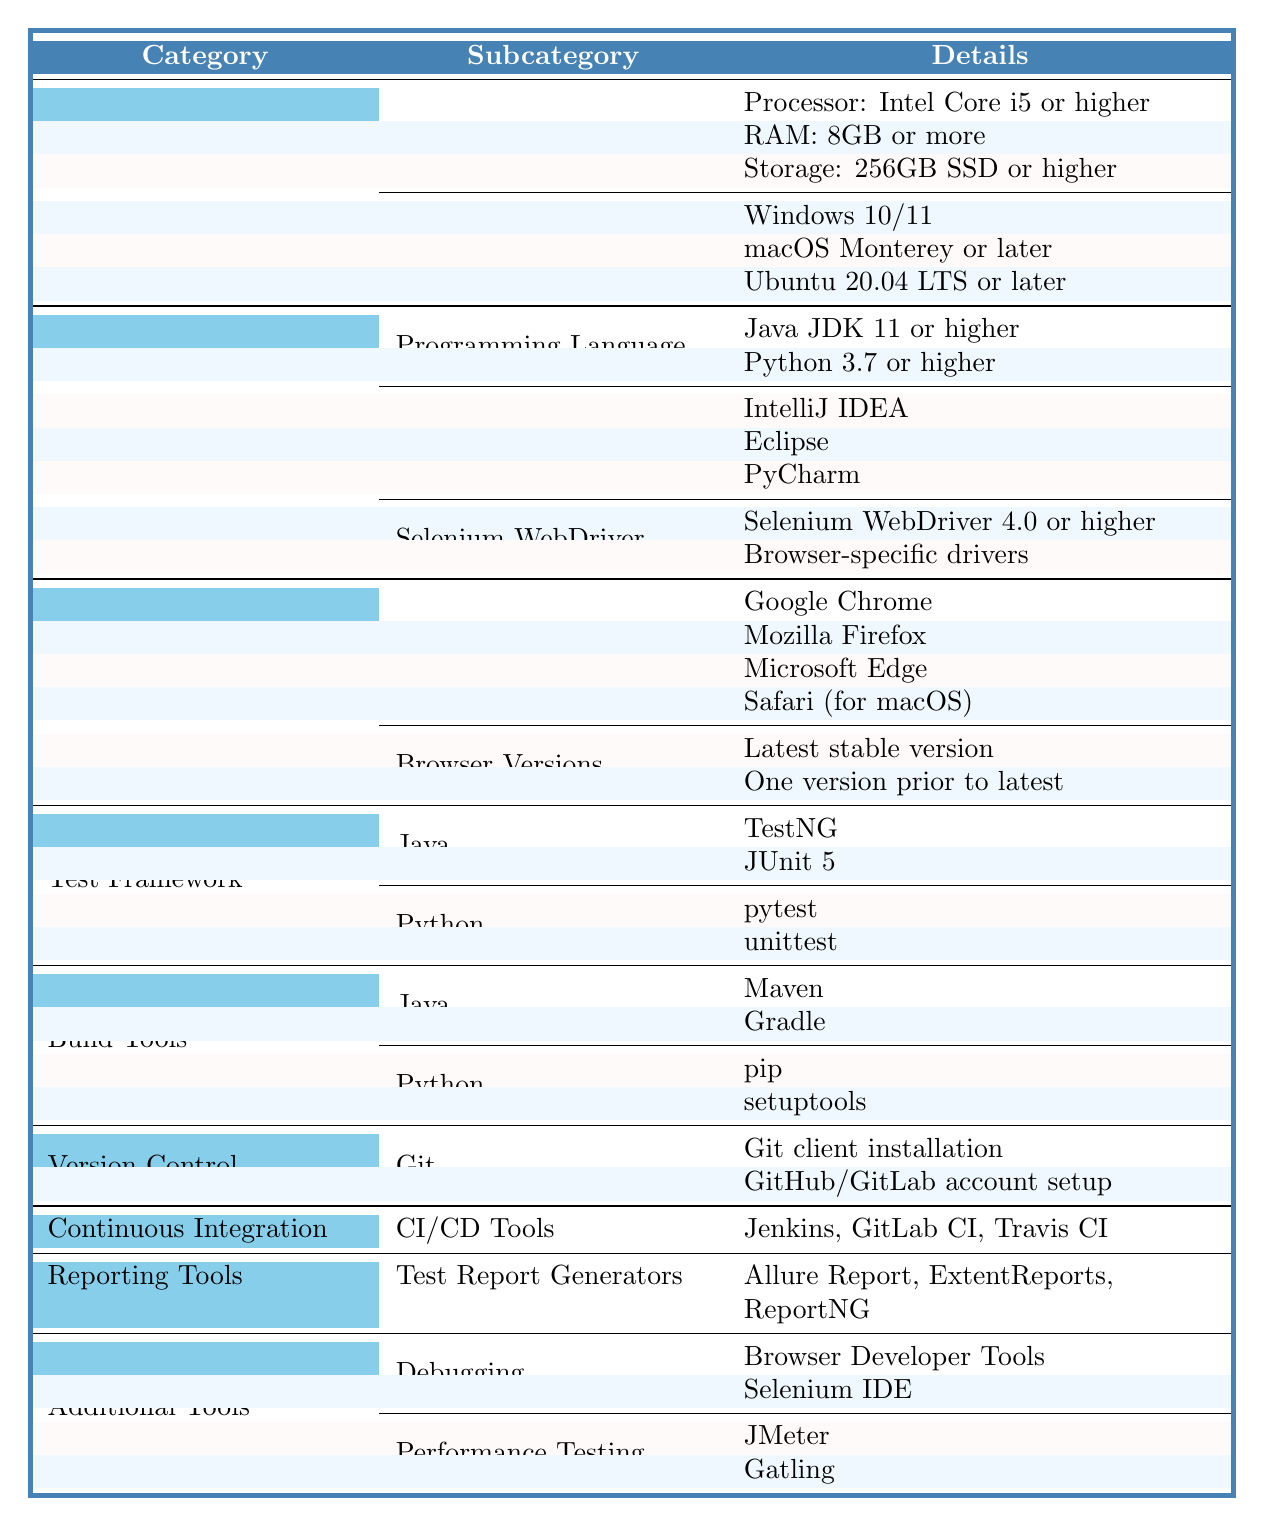What are the hardware requirements listed for the test environment? The table lists three hardware requirements under the "System Requirements" section: Processor: Intel Core i5 or higher, RAM: 8GB or more, and Storage: 256GB SSD or higher.
Answer: Intel Core i5 or higher, 8GB RAM, 256GB SSD or higher Is Python 3.7 the minimum required programming language version? The table states that the required version for Python is 3.7 or higher, indicating that Python 3.7 meets the minimum requirement.
Answer: Yes Which browsers are supported for testing? In the "Browser Setup" section, it lists four supported browsers: Google Chrome, Mozilla Firefox, Microsoft Edge, and Safari (for macOS).
Answer: Google Chrome, Mozilla Firefox, Microsoft Edge, Safari How many different test frameworks are mentioned for Java? The table lists two test frameworks under the "Test Framework" category for Java, which are TestNG and JUnit 5.
Answer: 2 Does the checklist recommend using the latest stable browser version? Under the "Browser Versions" section, it specifies that using the latest stable version is recommended, which indicates that it is advised to do so.
Answer: Yes What is the total number of IDEs mentioned in the table? The table lists three IDEs under the "Software Installation" section, specifically IntelliJ IDEA, Eclipse, and PyCharm, so the total is three.
Answer: 3 How does the number of Java options for build tools compare to Python options? For Java, there are two options listed: Maven and Gradle. For Python, there are also two options: pip and setuptools. Thus, both have the same number of options.
Answer: They are equal Which test reports generators are included in the reporting tools? The table specifies three test report generators under "Reporting Tools": Allure Report, ExtentReports, and ReportNG.
Answer: Allure Report, ExtentReports, ReportNG Is there any requirement for a specific version of a CI/CD tool? The table lists CI/CD tools like Jenkins, GitLab CI, and Travis CI but does not specify a required version for these tools.
Answer: No How many additional tools for performance testing are mentioned? Under the "Additional Tools" section, there are two performance testing tools mentioned: JMeter and Gatling.
Answer: 2 